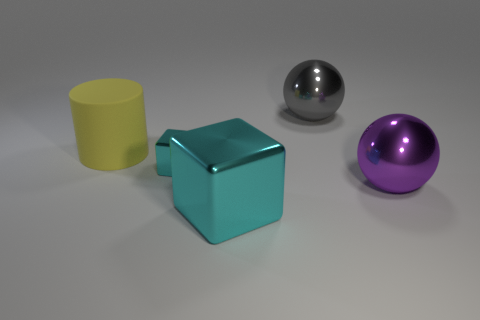Add 3 cyan things. How many objects exist? 8 Subtract all spheres. How many objects are left? 3 Subtract all gray shiny objects. Subtract all cubes. How many objects are left? 2 Add 4 cyan blocks. How many cyan blocks are left? 6 Add 1 yellow rubber things. How many yellow rubber things exist? 2 Subtract 0 green cylinders. How many objects are left? 5 